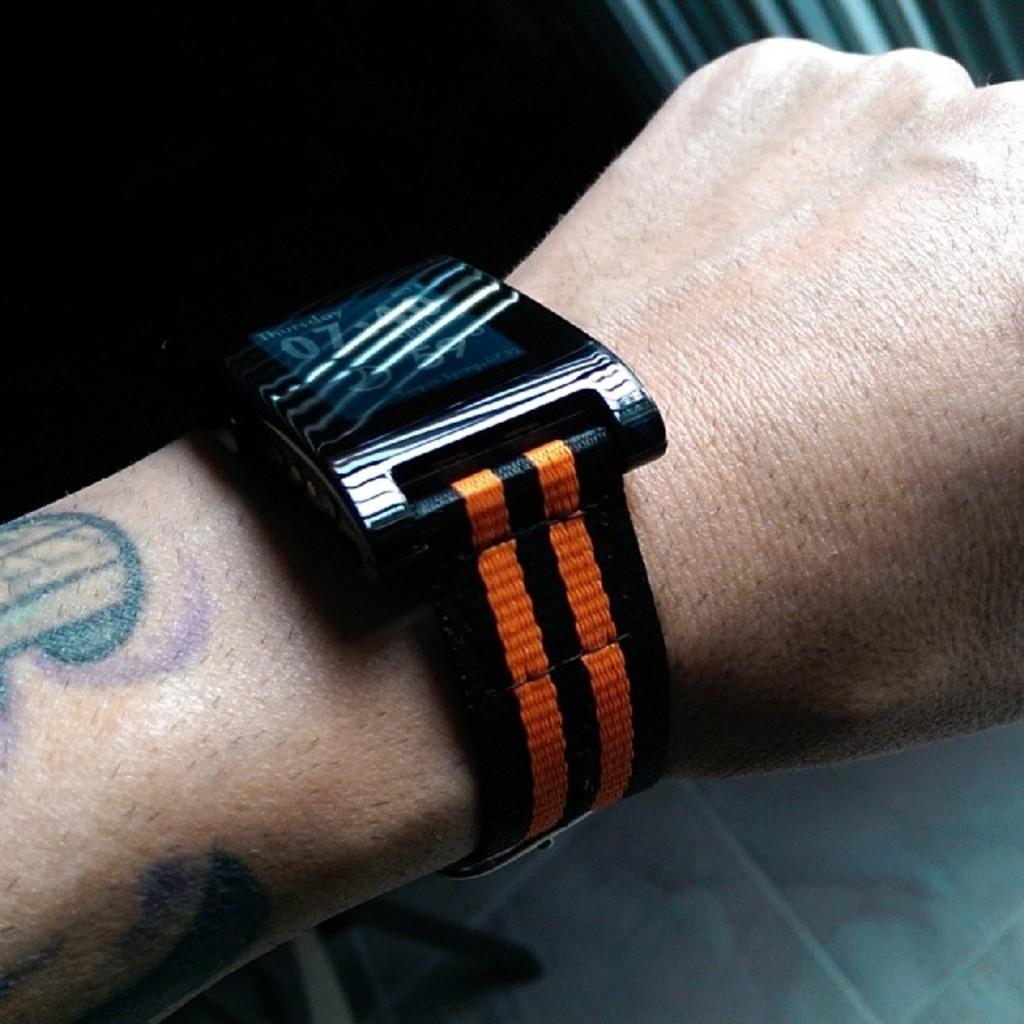What is the date on the watch?
Offer a very short reply. Thursday. 